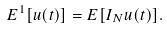<formula> <loc_0><loc_0><loc_500><loc_500>E ^ { 1 } [ u ( t ) ] = E [ I _ { N } u ( t ) ] .</formula> 